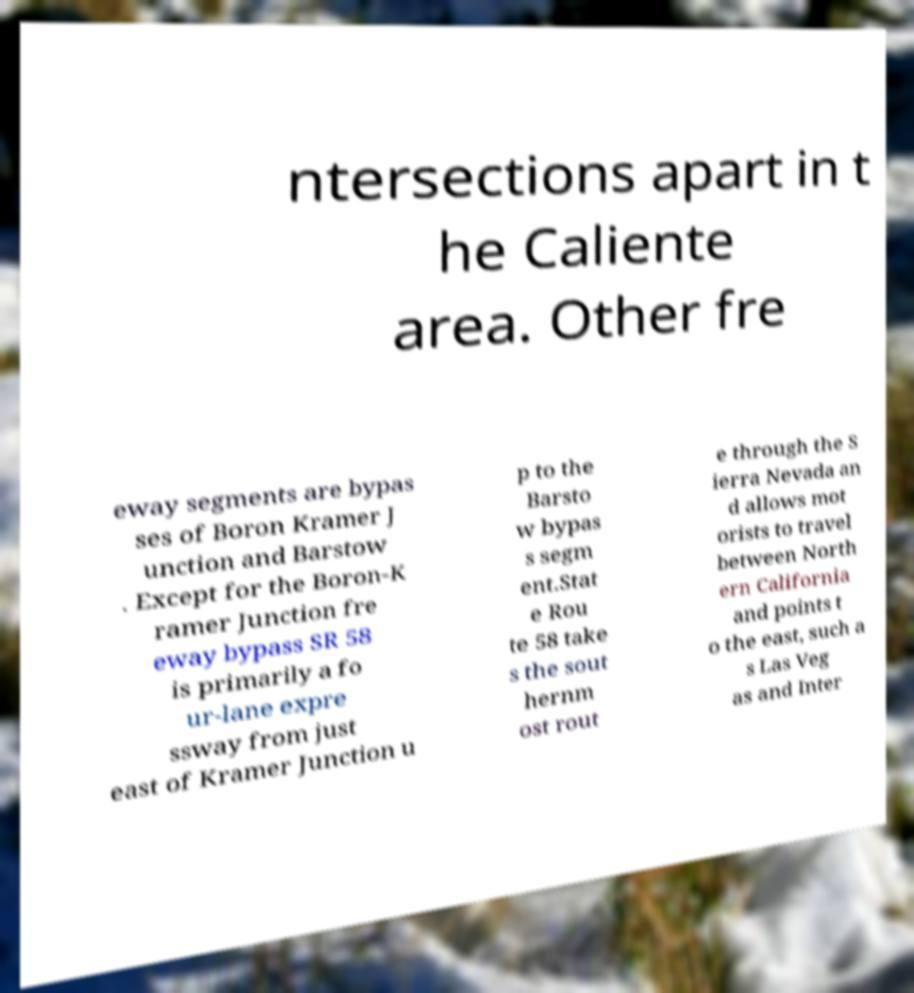Can you accurately transcribe the text from the provided image for me? ntersections apart in t he Caliente area. Other fre eway segments are bypas ses of Boron Kramer J unction and Barstow . Except for the Boron-K ramer Junction fre eway bypass SR 58 is primarily a fo ur-lane expre ssway from just east of Kramer Junction u p to the Barsto w bypas s segm ent.Stat e Rou te 58 take s the sout hernm ost rout e through the S ierra Nevada an d allows mot orists to travel between North ern California and points t o the east, such a s Las Veg as and Inter 